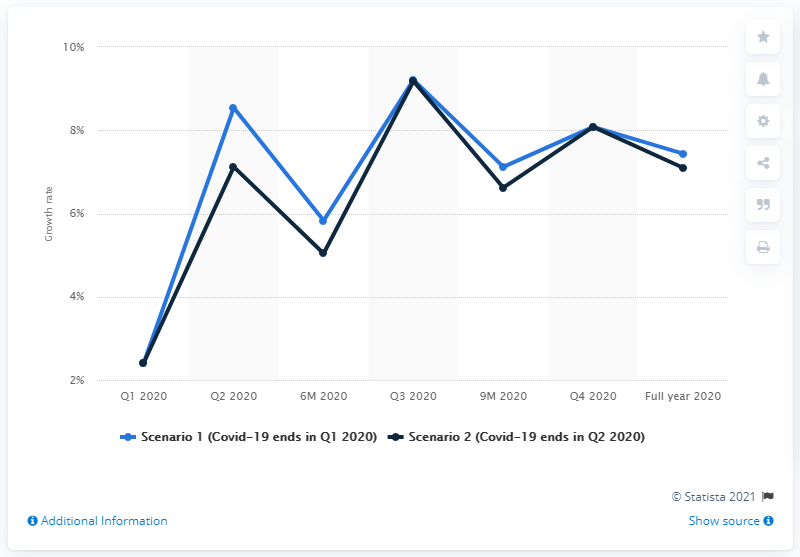Mention a couple of crucial points in this snapshot. The projection was that the industry sector is expected to grow by 7.1% if the COVID-19 pandemic is contained in the second quarter of 2020. 